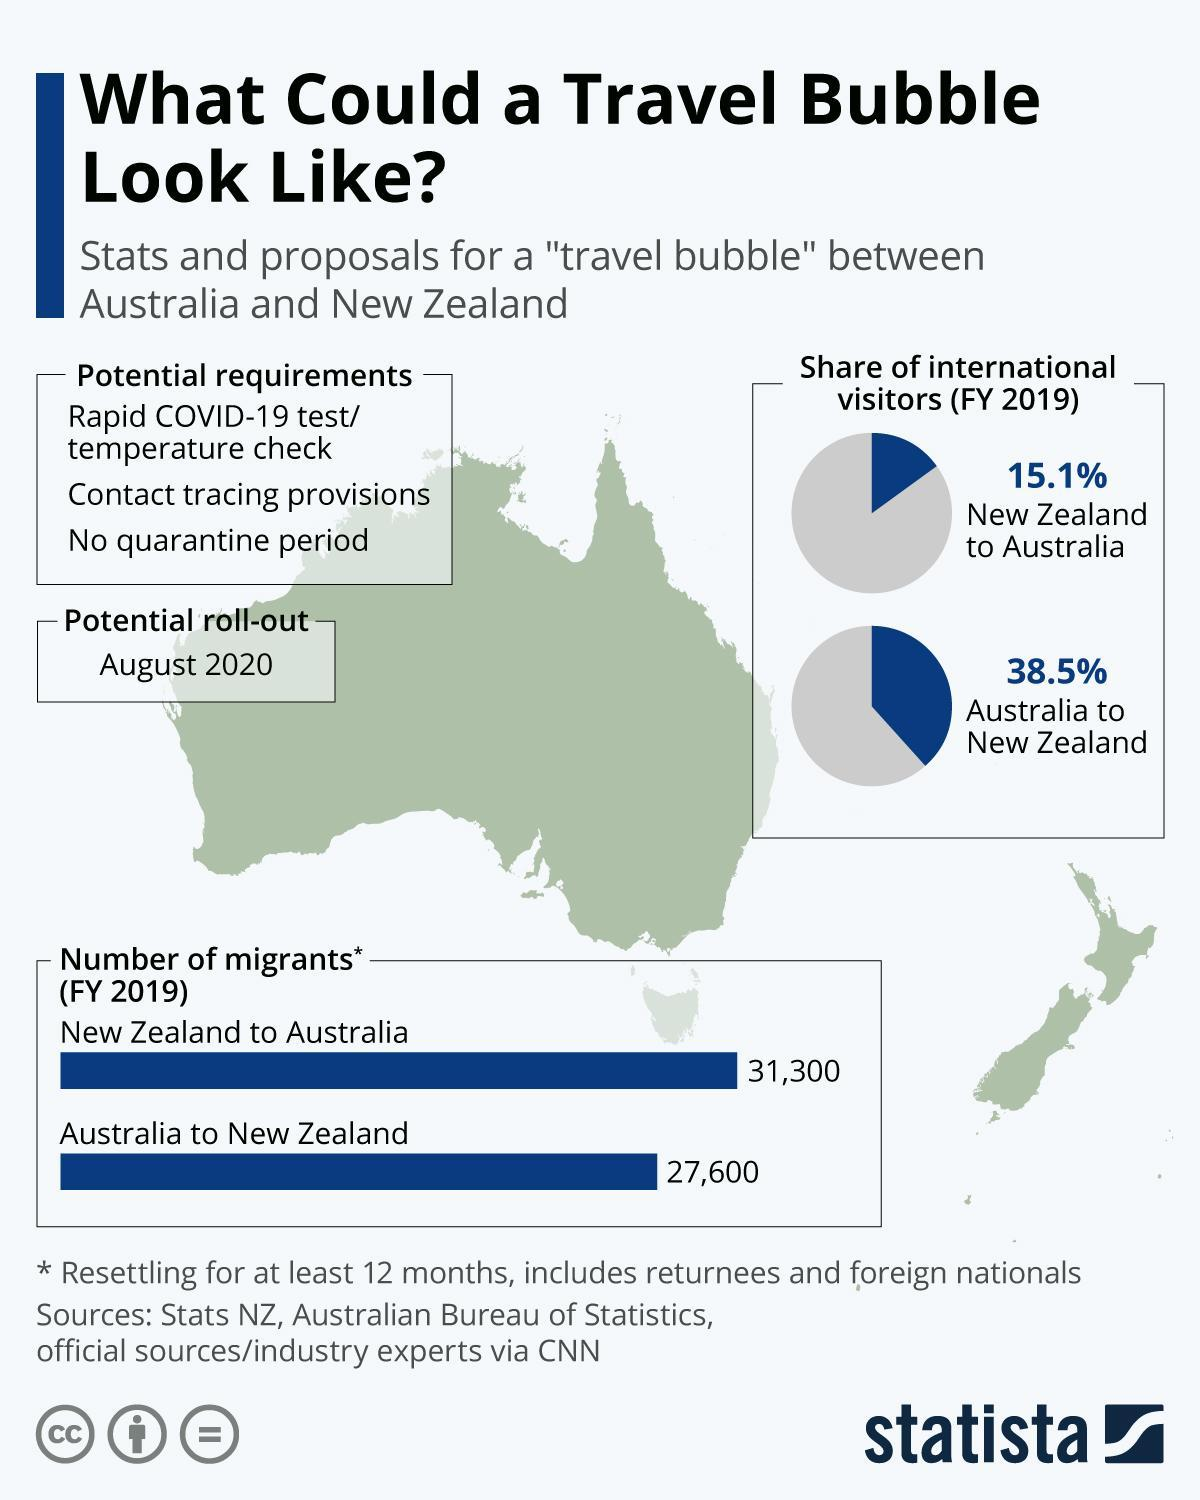What is listed third in the potential requirements for travel?
Answer the question with a short phrase. No quarantine period What comes second in the potential requirements for travel? contact tracing provisions When was the travel bubble plan likely to be introduced? August 2020 In 2019 a higher number of people migrated to which country? Australia 